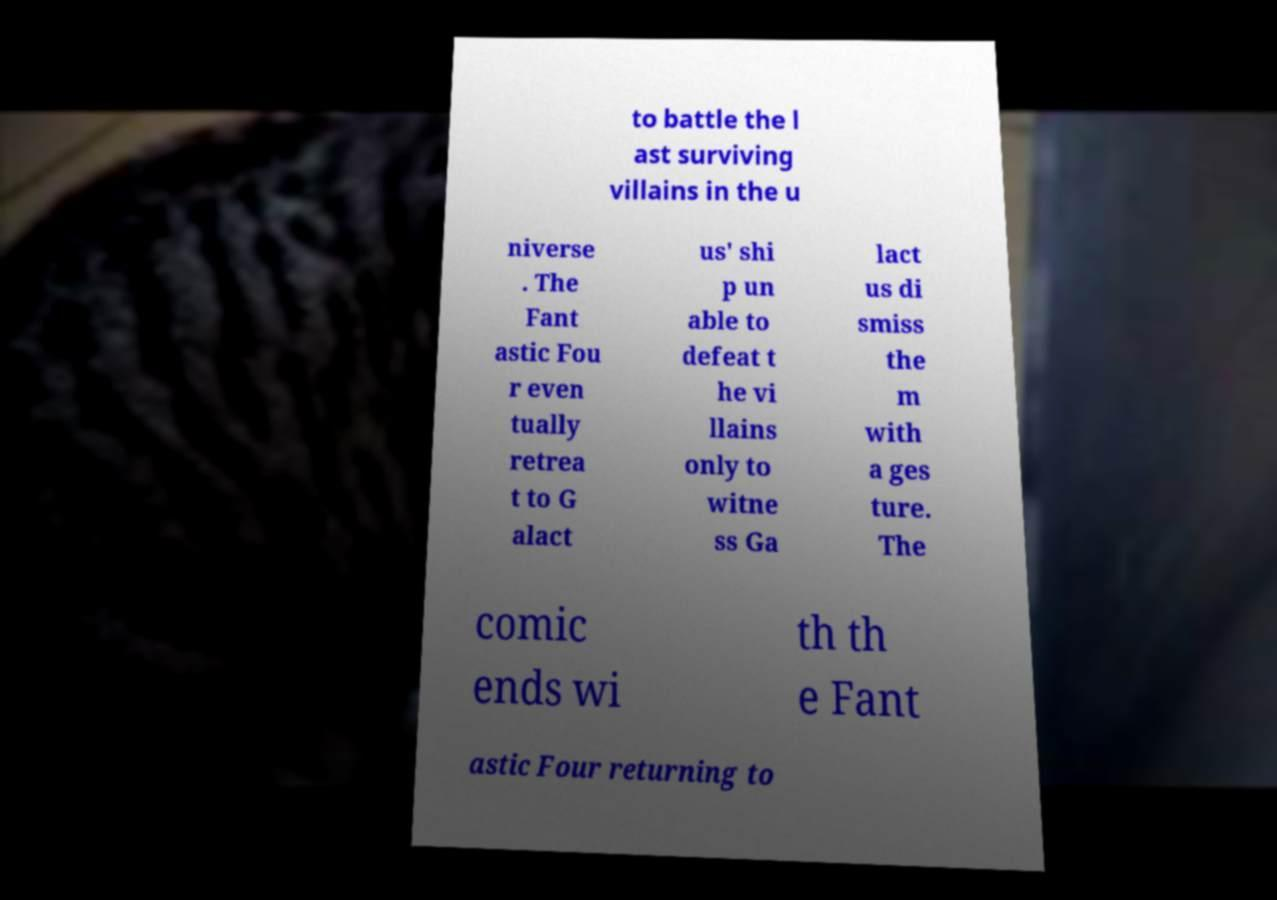I need the written content from this picture converted into text. Can you do that? to battle the l ast surviving villains in the u niverse . The Fant astic Fou r even tually retrea t to G alact us' shi p un able to defeat t he vi llains only to witne ss Ga lact us di smiss the m with a ges ture. The comic ends wi th th e Fant astic Four returning to 